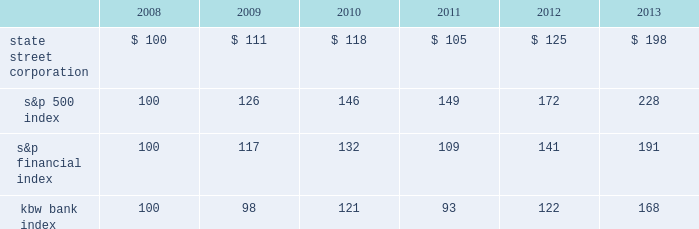Shareholder return performance presentation the graph presented below compares the cumulative total shareholder return on state street's common stock to the cumulative total return of the s&p 500 index , the s&p financial index and the kbw bank index over a five- year period .
The cumulative total shareholder return assumes the investment of $ 100 in state street common stock and in each index on december 31 , 2008 at the closing price on the last trading day of 2008 , and also assumes reinvestment of common stock dividends .
The s&p financial index is a publicly available measure of 81 of the standard & poor's 500 companies , representing 17 diversified financial services companies , 22 insurance companies , 19 real estate companies and 23 banking companies .
The kbw bank index seeks to reflect the performance of banks and thrifts that are publicly traded in the u.s. , and is composed of 24 leading national money center and regional banks and thrifts. .

What percent increase would shareholders receive between 2008 and 2013? 
Computations: ((198 - 100) / 100)
Answer: 0.98. 